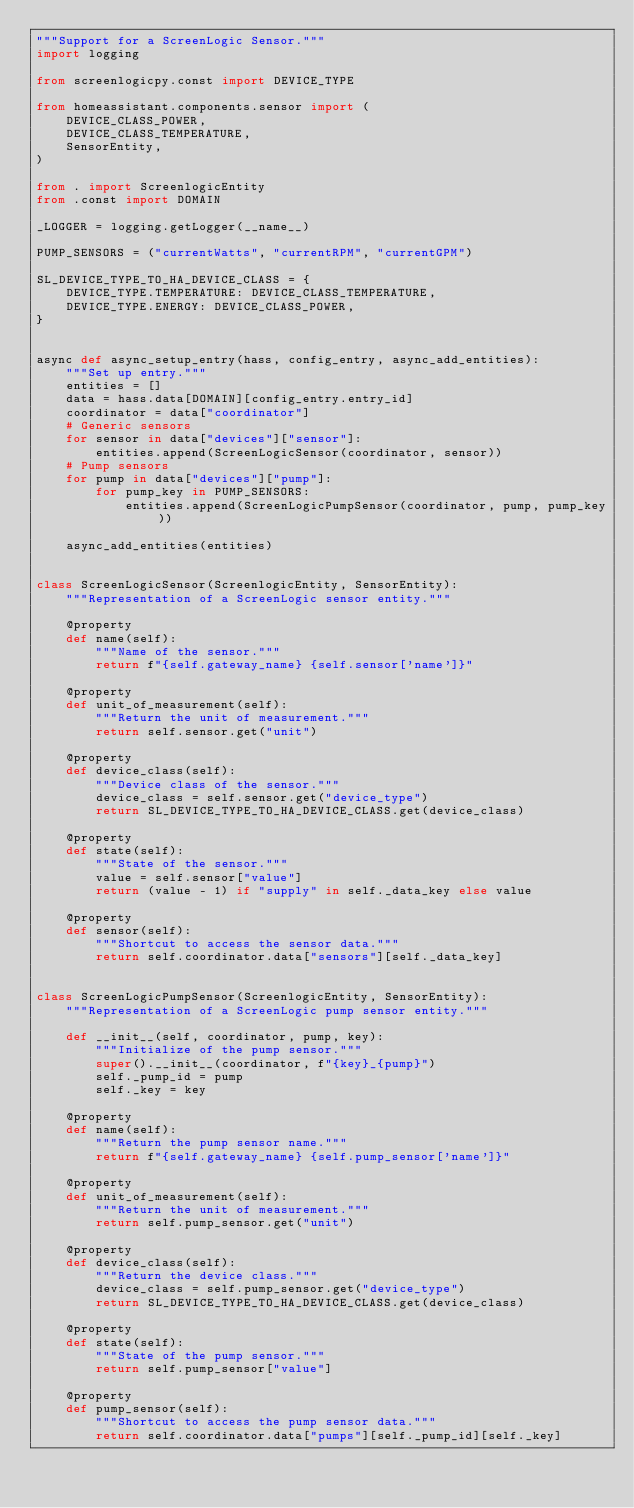Convert code to text. <code><loc_0><loc_0><loc_500><loc_500><_Python_>"""Support for a ScreenLogic Sensor."""
import logging

from screenlogicpy.const import DEVICE_TYPE

from homeassistant.components.sensor import (
    DEVICE_CLASS_POWER,
    DEVICE_CLASS_TEMPERATURE,
    SensorEntity,
)

from . import ScreenlogicEntity
from .const import DOMAIN

_LOGGER = logging.getLogger(__name__)

PUMP_SENSORS = ("currentWatts", "currentRPM", "currentGPM")

SL_DEVICE_TYPE_TO_HA_DEVICE_CLASS = {
    DEVICE_TYPE.TEMPERATURE: DEVICE_CLASS_TEMPERATURE,
    DEVICE_TYPE.ENERGY: DEVICE_CLASS_POWER,
}


async def async_setup_entry(hass, config_entry, async_add_entities):
    """Set up entry."""
    entities = []
    data = hass.data[DOMAIN][config_entry.entry_id]
    coordinator = data["coordinator"]
    # Generic sensors
    for sensor in data["devices"]["sensor"]:
        entities.append(ScreenLogicSensor(coordinator, sensor))
    # Pump sensors
    for pump in data["devices"]["pump"]:
        for pump_key in PUMP_SENSORS:
            entities.append(ScreenLogicPumpSensor(coordinator, pump, pump_key))

    async_add_entities(entities)


class ScreenLogicSensor(ScreenlogicEntity, SensorEntity):
    """Representation of a ScreenLogic sensor entity."""

    @property
    def name(self):
        """Name of the sensor."""
        return f"{self.gateway_name} {self.sensor['name']}"

    @property
    def unit_of_measurement(self):
        """Return the unit of measurement."""
        return self.sensor.get("unit")

    @property
    def device_class(self):
        """Device class of the sensor."""
        device_class = self.sensor.get("device_type")
        return SL_DEVICE_TYPE_TO_HA_DEVICE_CLASS.get(device_class)

    @property
    def state(self):
        """State of the sensor."""
        value = self.sensor["value"]
        return (value - 1) if "supply" in self._data_key else value

    @property
    def sensor(self):
        """Shortcut to access the sensor data."""
        return self.coordinator.data["sensors"][self._data_key]


class ScreenLogicPumpSensor(ScreenlogicEntity, SensorEntity):
    """Representation of a ScreenLogic pump sensor entity."""

    def __init__(self, coordinator, pump, key):
        """Initialize of the pump sensor."""
        super().__init__(coordinator, f"{key}_{pump}")
        self._pump_id = pump
        self._key = key

    @property
    def name(self):
        """Return the pump sensor name."""
        return f"{self.gateway_name} {self.pump_sensor['name']}"

    @property
    def unit_of_measurement(self):
        """Return the unit of measurement."""
        return self.pump_sensor.get("unit")

    @property
    def device_class(self):
        """Return the device class."""
        device_class = self.pump_sensor.get("device_type")
        return SL_DEVICE_TYPE_TO_HA_DEVICE_CLASS.get(device_class)

    @property
    def state(self):
        """State of the pump sensor."""
        return self.pump_sensor["value"]

    @property
    def pump_sensor(self):
        """Shortcut to access the pump sensor data."""
        return self.coordinator.data["pumps"][self._pump_id][self._key]
</code> 